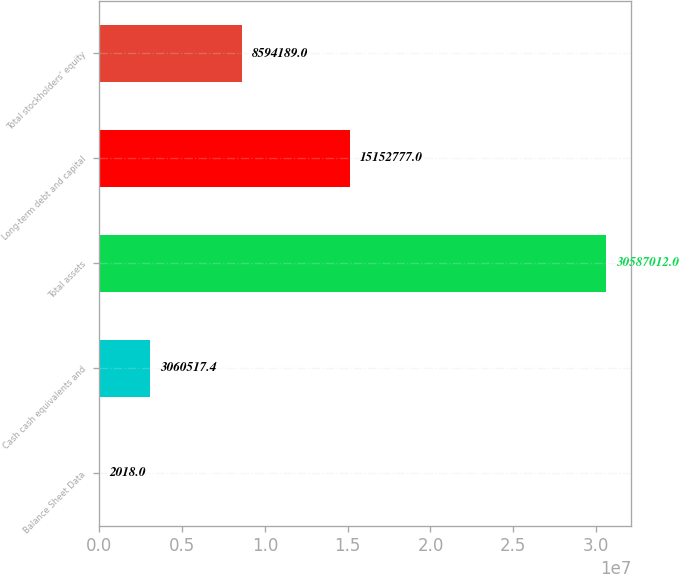Convert chart. <chart><loc_0><loc_0><loc_500><loc_500><bar_chart><fcel>Balance Sheet Data<fcel>Cash cash equivalents and<fcel>Total assets<fcel>Long-term debt and capital<fcel>Total stockholders' equity<nl><fcel>2018<fcel>3.06052e+06<fcel>3.0587e+07<fcel>1.51528e+07<fcel>8.59419e+06<nl></chart> 